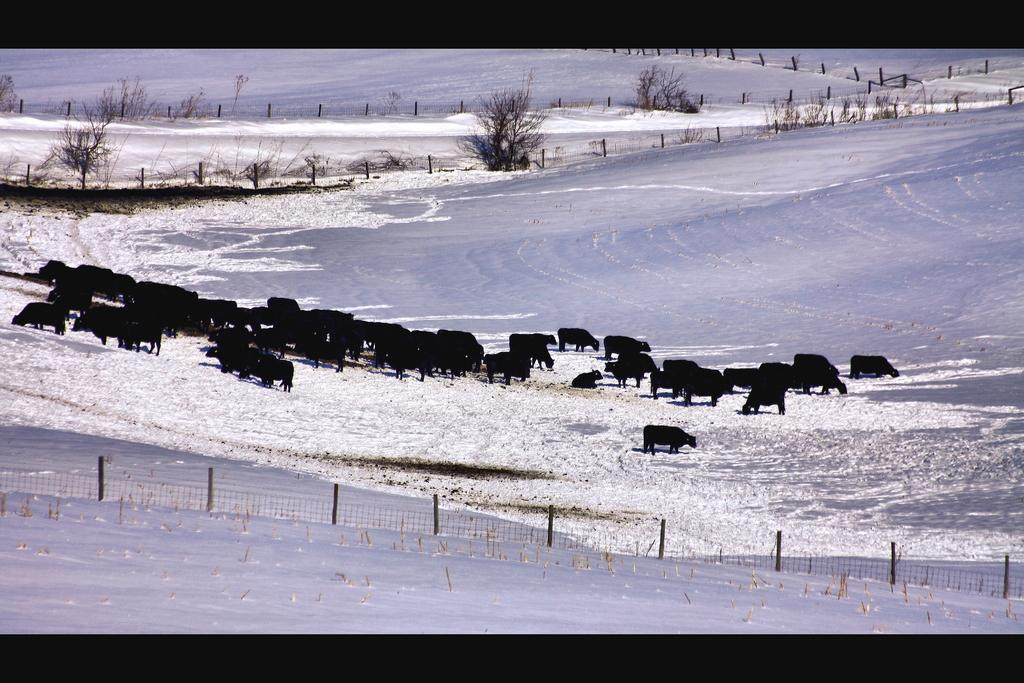What is the predominant weather condition in the image? There is snow in the image, indicating a cold and wintry condition. What type of structure can be seen in the image? There is a fence in the image. What type of vegetation is present in the image? There are trees in the image. What type of animals can be seen in the image? There are black color animals in the image. Can you see a squirrel holding a match in the image? There is no squirrel or match present in the image. 